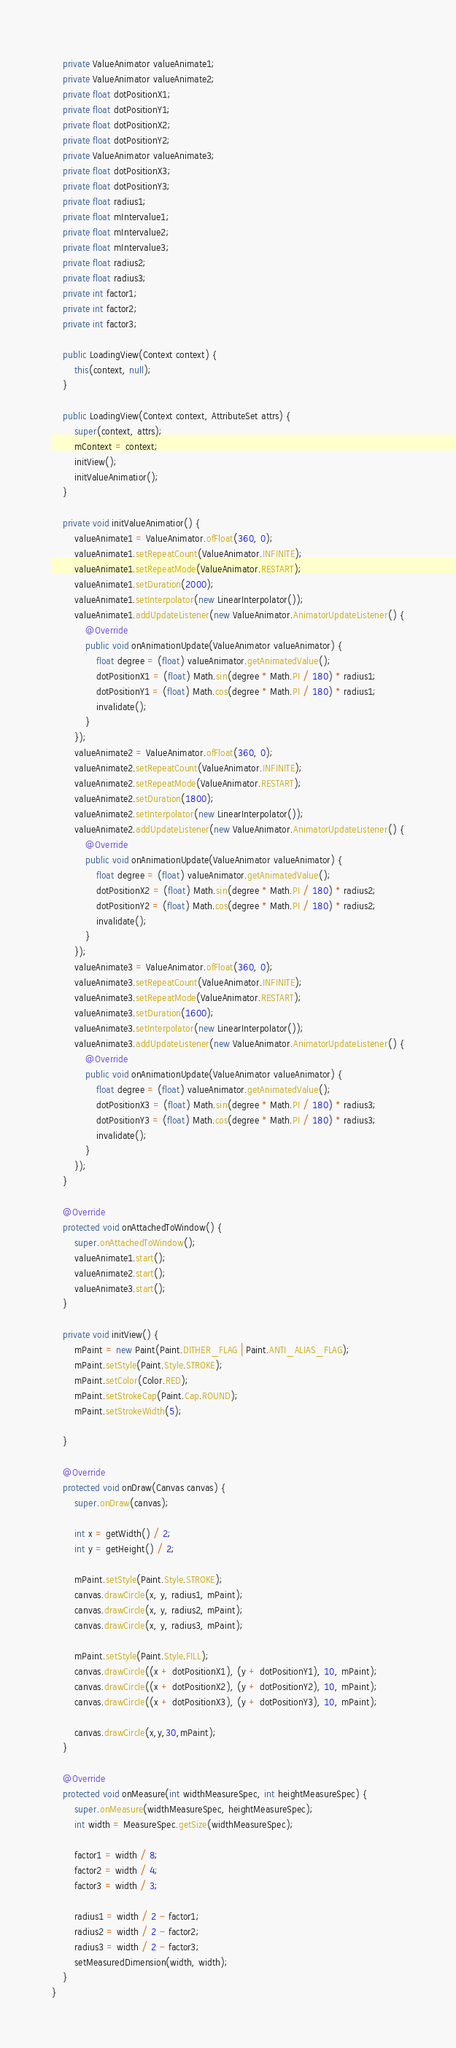Convert code to text. <code><loc_0><loc_0><loc_500><loc_500><_Java_>    private ValueAnimator valueAnimate1;
    private ValueAnimator valueAnimate2;
    private float dotPositionX1;
    private float dotPositionY1;
    private float dotPositionX2;
    private float dotPositionY2;
    private ValueAnimator valueAnimate3;
    private float dotPositionX3;
    private float dotPositionY3;
    private float radius1;
    private float mIntervalue1;
    private float mIntervalue2;
    private float mIntervalue3;
    private float radius2;
    private float radius3;
    private int factor1;
    private int factor2;
    private int factor3;

    public LoadingView(Context context) {
        this(context, null);
    }

    public LoadingView(Context context, AttributeSet attrs) {
        super(context, attrs);
        mContext = context;
        initView();
        initValueAnimatior();
    }

    private void initValueAnimatior() {
        valueAnimate1 = ValueAnimator.ofFloat(360, 0);
        valueAnimate1.setRepeatCount(ValueAnimator.INFINITE);
        valueAnimate1.setRepeatMode(ValueAnimator.RESTART);
        valueAnimate1.setDuration(2000);
        valueAnimate1.setInterpolator(new LinearInterpolator());
        valueAnimate1.addUpdateListener(new ValueAnimator.AnimatorUpdateListener() {
            @Override
            public void onAnimationUpdate(ValueAnimator valueAnimator) {
                float degree = (float) valueAnimator.getAnimatedValue();
                dotPositionX1 = (float) Math.sin(degree * Math.PI / 180) * radius1;
                dotPositionY1 = (float) Math.cos(degree * Math.PI / 180) * radius1;
                invalidate();
            }
        });
        valueAnimate2 = ValueAnimator.ofFloat(360, 0);
        valueAnimate2.setRepeatCount(ValueAnimator.INFINITE);
        valueAnimate2.setRepeatMode(ValueAnimator.RESTART);
        valueAnimate2.setDuration(1800);
        valueAnimate2.setInterpolator(new LinearInterpolator());
        valueAnimate2.addUpdateListener(new ValueAnimator.AnimatorUpdateListener() {
            @Override
            public void onAnimationUpdate(ValueAnimator valueAnimator) {
                float degree = (float) valueAnimator.getAnimatedValue();
                dotPositionX2 = (float) Math.sin(degree * Math.PI / 180) * radius2;
                dotPositionY2 = (float) Math.cos(degree * Math.PI / 180) * radius2;
                invalidate();
            }
        });
        valueAnimate3 = ValueAnimator.ofFloat(360, 0);
        valueAnimate3.setRepeatCount(ValueAnimator.INFINITE);
        valueAnimate3.setRepeatMode(ValueAnimator.RESTART);
        valueAnimate3.setDuration(1600);
        valueAnimate3.setInterpolator(new LinearInterpolator());
        valueAnimate3.addUpdateListener(new ValueAnimator.AnimatorUpdateListener() {
            @Override
            public void onAnimationUpdate(ValueAnimator valueAnimator) {
                float degree = (float) valueAnimator.getAnimatedValue();
                dotPositionX3 = (float) Math.sin(degree * Math.PI / 180) * radius3;
                dotPositionY3 = (float) Math.cos(degree * Math.PI / 180) * radius3;
                invalidate();
            }
        });
    }

    @Override
    protected void onAttachedToWindow() {
        super.onAttachedToWindow();
        valueAnimate1.start();
        valueAnimate2.start();
        valueAnimate3.start();
    }

    private void initView() {
        mPaint = new Paint(Paint.DITHER_FLAG | Paint.ANTI_ALIAS_FLAG);
        mPaint.setStyle(Paint.Style.STROKE);
        mPaint.setColor(Color.RED);
        mPaint.setStrokeCap(Paint.Cap.ROUND);
        mPaint.setStrokeWidth(5);

    }

    @Override
    protected void onDraw(Canvas canvas) {
        super.onDraw(canvas);

        int x = getWidth() / 2;
        int y = getHeight() / 2;

        mPaint.setStyle(Paint.Style.STROKE);
        canvas.drawCircle(x, y, radius1, mPaint);
        canvas.drawCircle(x, y, radius2, mPaint);
        canvas.drawCircle(x, y, radius3, mPaint);

        mPaint.setStyle(Paint.Style.FILL);
        canvas.drawCircle((x + dotPositionX1), (y + dotPositionY1), 10, mPaint);
        canvas.drawCircle((x + dotPositionX2), (y + dotPositionY2), 10, mPaint);
        canvas.drawCircle((x + dotPositionX3), (y + dotPositionY3), 10, mPaint);

        canvas.drawCircle(x,y,30,mPaint);
    }

    @Override
    protected void onMeasure(int widthMeasureSpec, int heightMeasureSpec) {
        super.onMeasure(widthMeasureSpec, heightMeasureSpec);
        int width = MeasureSpec.getSize(widthMeasureSpec);

        factor1 = width / 8;
        factor2 = width / 4;
        factor3 = width / 3;

        radius1 = width / 2 - factor1;
        radius2 = width / 2 - factor2;
        radius3 = width / 2 - factor3;
        setMeasuredDimension(width, width);
    }
}

</code> 